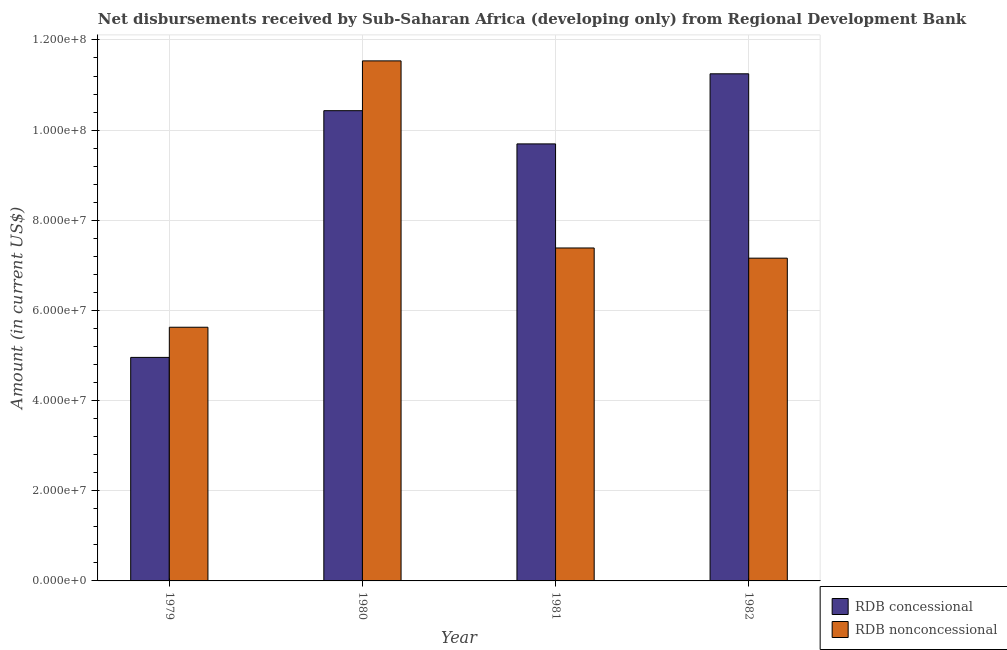How many groups of bars are there?
Your answer should be compact. 4. Are the number of bars on each tick of the X-axis equal?
Provide a succinct answer. Yes. How many bars are there on the 3rd tick from the left?
Provide a succinct answer. 2. What is the label of the 4th group of bars from the left?
Give a very brief answer. 1982. In how many cases, is the number of bars for a given year not equal to the number of legend labels?
Your answer should be very brief. 0. What is the net concessional disbursements from rdb in 1980?
Ensure brevity in your answer.  1.04e+08. Across all years, what is the maximum net concessional disbursements from rdb?
Ensure brevity in your answer.  1.12e+08. Across all years, what is the minimum net non concessional disbursements from rdb?
Ensure brevity in your answer.  5.63e+07. In which year was the net concessional disbursements from rdb maximum?
Your answer should be very brief. 1982. In which year was the net concessional disbursements from rdb minimum?
Provide a short and direct response. 1979. What is the total net non concessional disbursements from rdb in the graph?
Your answer should be compact. 3.17e+08. What is the difference between the net non concessional disbursements from rdb in 1979 and that in 1982?
Provide a short and direct response. -1.53e+07. What is the difference between the net non concessional disbursements from rdb in 1979 and the net concessional disbursements from rdb in 1981?
Offer a terse response. -1.76e+07. What is the average net concessional disbursements from rdb per year?
Give a very brief answer. 9.08e+07. What is the ratio of the net concessional disbursements from rdb in 1980 to that in 1982?
Your answer should be compact. 0.93. Is the difference between the net concessional disbursements from rdb in 1980 and 1981 greater than the difference between the net non concessional disbursements from rdb in 1980 and 1981?
Ensure brevity in your answer.  No. What is the difference between the highest and the second highest net concessional disbursements from rdb?
Your answer should be very brief. 8.18e+06. What is the difference between the highest and the lowest net concessional disbursements from rdb?
Your response must be concise. 6.29e+07. In how many years, is the net non concessional disbursements from rdb greater than the average net non concessional disbursements from rdb taken over all years?
Your answer should be compact. 1. Is the sum of the net concessional disbursements from rdb in 1979 and 1981 greater than the maximum net non concessional disbursements from rdb across all years?
Give a very brief answer. Yes. What does the 2nd bar from the left in 1979 represents?
Make the answer very short. RDB nonconcessional. What does the 1st bar from the right in 1979 represents?
Give a very brief answer. RDB nonconcessional. What is the difference between two consecutive major ticks on the Y-axis?
Your answer should be compact. 2.00e+07. How are the legend labels stacked?
Offer a terse response. Vertical. What is the title of the graph?
Offer a terse response. Net disbursements received by Sub-Saharan Africa (developing only) from Regional Development Bank. Does "Under-5(male)" appear as one of the legend labels in the graph?
Provide a short and direct response. No. What is the Amount (in current US$) of RDB concessional in 1979?
Offer a very short reply. 4.96e+07. What is the Amount (in current US$) in RDB nonconcessional in 1979?
Keep it short and to the point. 5.63e+07. What is the Amount (in current US$) in RDB concessional in 1980?
Your response must be concise. 1.04e+08. What is the Amount (in current US$) of RDB nonconcessional in 1980?
Your answer should be compact. 1.15e+08. What is the Amount (in current US$) of RDB concessional in 1981?
Ensure brevity in your answer.  9.69e+07. What is the Amount (in current US$) of RDB nonconcessional in 1981?
Your answer should be compact. 7.39e+07. What is the Amount (in current US$) of RDB concessional in 1982?
Provide a short and direct response. 1.12e+08. What is the Amount (in current US$) of RDB nonconcessional in 1982?
Provide a succinct answer. 7.16e+07. Across all years, what is the maximum Amount (in current US$) in RDB concessional?
Your answer should be compact. 1.12e+08. Across all years, what is the maximum Amount (in current US$) of RDB nonconcessional?
Offer a terse response. 1.15e+08. Across all years, what is the minimum Amount (in current US$) in RDB concessional?
Give a very brief answer. 4.96e+07. Across all years, what is the minimum Amount (in current US$) in RDB nonconcessional?
Your response must be concise. 5.63e+07. What is the total Amount (in current US$) of RDB concessional in the graph?
Your response must be concise. 3.63e+08. What is the total Amount (in current US$) in RDB nonconcessional in the graph?
Your answer should be very brief. 3.17e+08. What is the difference between the Amount (in current US$) of RDB concessional in 1979 and that in 1980?
Your answer should be compact. -5.47e+07. What is the difference between the Amount (in current US$) of RDB nonconcessional in 1979 and that in 1980?
Give a very brief answer. -5.91e+07. What is the difference between the Amount (in current US$) in RDB concessional in 1979 and that in 1981?
Your answer should be very brief. -4.74e+07. What is the difference between the Amount (in current US$) of RDB nonconcessional in 1979 and that in 1981?
Your response must be concise. -1.76e+07. What is the difference between the Amount (in current US$) in RDB concessional in 1979 and that in 1982?
Your answer should be compact. -6.29e+07. What is the difference between the Amount (in current US$) of RDB nonconcessional in 1979 and that in 1982?
Give a very brief answer. -1.53e+07. What is the difference between the Amount (in current US$) of RDB concessional in 1980 and that in 1981?
Your response must be concise. 7.37e+06. What is the difference between the Amount (in current US$) in RDB nonconcessional in 1980 and that in 1981?
Ensure brevity in your answer.  4.15e+07. What is the difference between the Amount (in current US$) in RDB concessional in 1980 and that in 1982?
Your answer should be compact. -8.18e+06. What is the difference between the Amount (in current US$) of RDB nonconcessional in 1980 and that in 1982?
Make the answer very short. 4.38e+07. What is the difference between the Amount (in current US$) of RDB concessional in 1981 and that in 1982?
Ensure brevity in your answer.  -1.55e+07. What is the difference between the Amount (in current US$) in RDB nonconcessional in 1981 and that in 1982?
Offer a terse response. 2.26e+06. What is the difference between the Amount (in current US$) in RDB concessional in 1979 and the Amount (in current US$) in RDB nonconcessional in 1980?
Ensure brevity in your answer.  -6.58e+07. What is the difference between the Amount (in current US$) in RDB concessional in 1979 and the Amount (in current US$) in RDB nonconcessional in 1981?
Offer a terse response. -2.43e+07. What is the difference between the Amount (in current US$) of RDB concessional in 1979 and the Amount (in current US$) of RDB nonconcessional in 1982?
Provide a short and direct response. -2.20e+07. What is the difference between the Amount (in current US$) in RDB concessional in 1980 and the Amount (in current US$) in RDB nonconcessional in 1981?
Give a very brief answer. 3.05e+07. What is the difference between the Amount (in current US$) in RDB concessional in 1980 and the Amount (in current US$) in RDB nonconcessional in 1982?
Keep it short and to the point. 3.27e+07. What is the difference between the Amount (in current US$) of RDB concessional in 1981 and the Amount (in current US$) of RDB nonconcessional in 1982?
Offer a very short reply. 2.53e+07. What is the average Amount (in current US$) in RDB concessional per year?
Offer a terse response. 9.08e+07. What is the average Amount (in current US$) in RDB nonconcessional per year?
Give a very brief answer. 7.93e+07. In the year 1979, what is the difference between the Amount (in current US$) in RDB concessional and Amount (in current US$) in RDB nonconcessional?
Your response must be concise. -6.69e+06. In the year 1980, what is the difference between the Amount (in current US$) in RDB concessional and Amount (in current US$) in RDB nonconcessional?
Keep it short and to the point. -1.10e+07. In the year 1981, what is the difference between the Amount (in current US$) of RDB concessional and Amount (in current US$) of RDB nonconcessional?
Give a very brief answer. 2.31e+07. In the year 1982, what is the difference between the Amount (in current US$) in RDB concessional and Amount (in current US$) in RDB nonconcessional?
Give a very brief answer. 4.09e+07. What is the ratio of the Amount (in current US$) in RDB concessional in 1979 to that in 1980?
Give a very brief answer. 0.48. What is the ratio of the Amount (in current US$) in RDB nonconcessional in 1979 to that in 1980?
Your answer should be compact. 0.49. What is the ratio of the Amount (in current US$) of RDB concessional in 1979 to that in 1981?
Your response must be concise. 0.51. What is the ratio of the Amount (in current US$) in RDB nonconcessional in 1979 to that in 1981?
Keep it short and to the point. 0.76. What is the ratio of the Amount (in current US$) of RDB concessional in 1979 to that in 1982?
Provide a short and direct response. 0.44. What is the ratio of the Amount (in current US$) in RDB nonconcessional in 1979 to that in 1982?
Keep it short and to the point. 0.79. What is the ratio of the Amount (in current US$) of RDB concessional in 1980 to that in 1981?
Ensure brevity in your answer.  1.08. What is the ratio of the Amount (in current US$) in RDB nonconcessional in 1980 to that in 1981?
Keep it short and to the point. 1.56. What is the ratio of the Amount (in current US$) in RDB concessional in 1980 to that in 1982?
Your response must be concise. 0.93. What is the ratio of the Amount (in current US$) in RDB nonconcessional in 1980 to that in 1982?
Your answer should be very brief. 1.61. What is the ratio of the Amount (in current US$) of RDB concessional in 1981 to that in 1982?
Make the answer very short. 0.86. What is the ratio of the Amount (in current US$) of RDB nonconcessional in 1981 to that in 1982?
Your response must be concise. 1.03. What is the difference between the highest and the second highest Amount (in current US$) of RDB concessional?
Ensure brevity in your answer.  8.18e+06. What is the difference between the highest and the second highest Amount (in current US$) in RDB nonconcessional?
Your response must be concise. 4.15e+07. What is the difference between the highest and the lowest Amount (in current US$) of RDB concessional?
Your answer should be very brief. 6.29e+07. What is the difference between the highest and the lowest Amount (in current US$) in RDB nonconcessional?
Provide a succinct answer. 5.91e+07. 